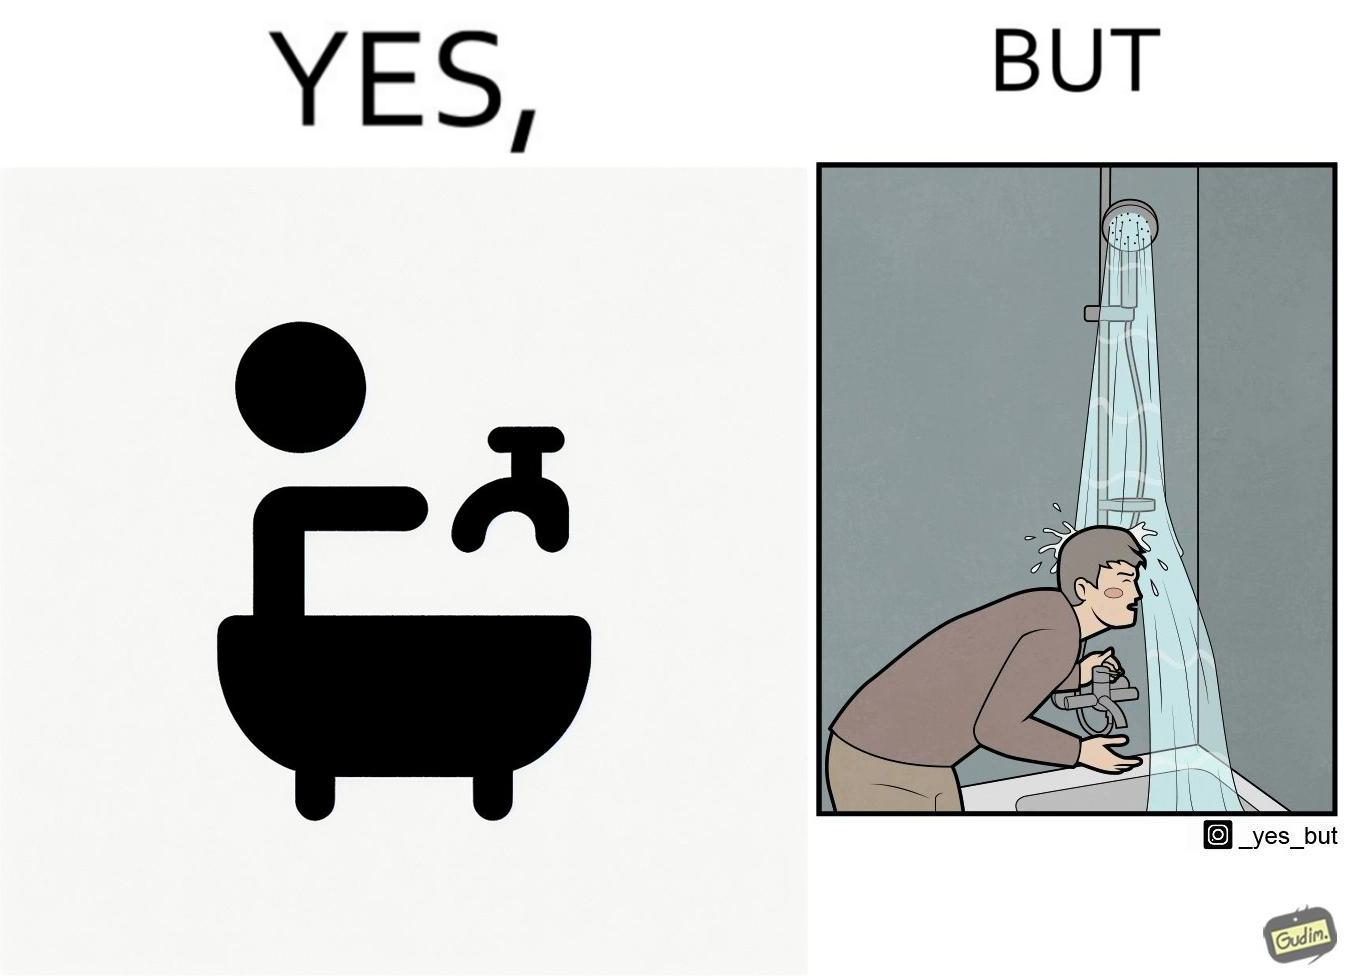Would you classify this image as satirical? Yes, this image is satirical. 